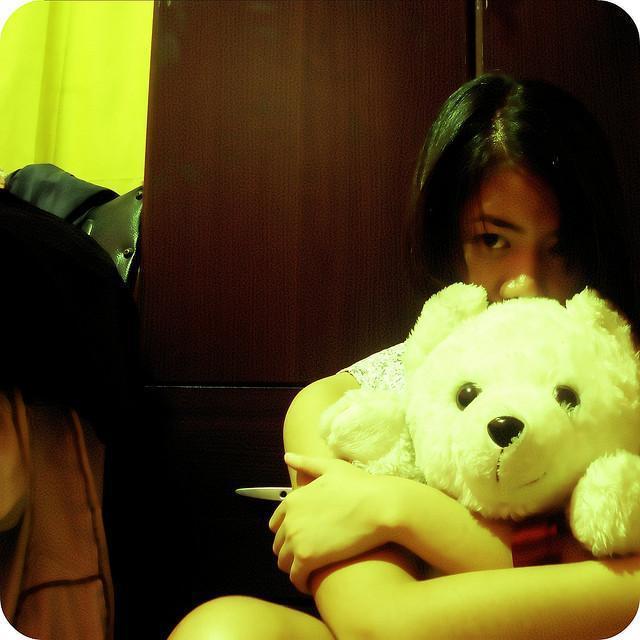How many teddy bears can you see?
Give a very brief answer. 1. 